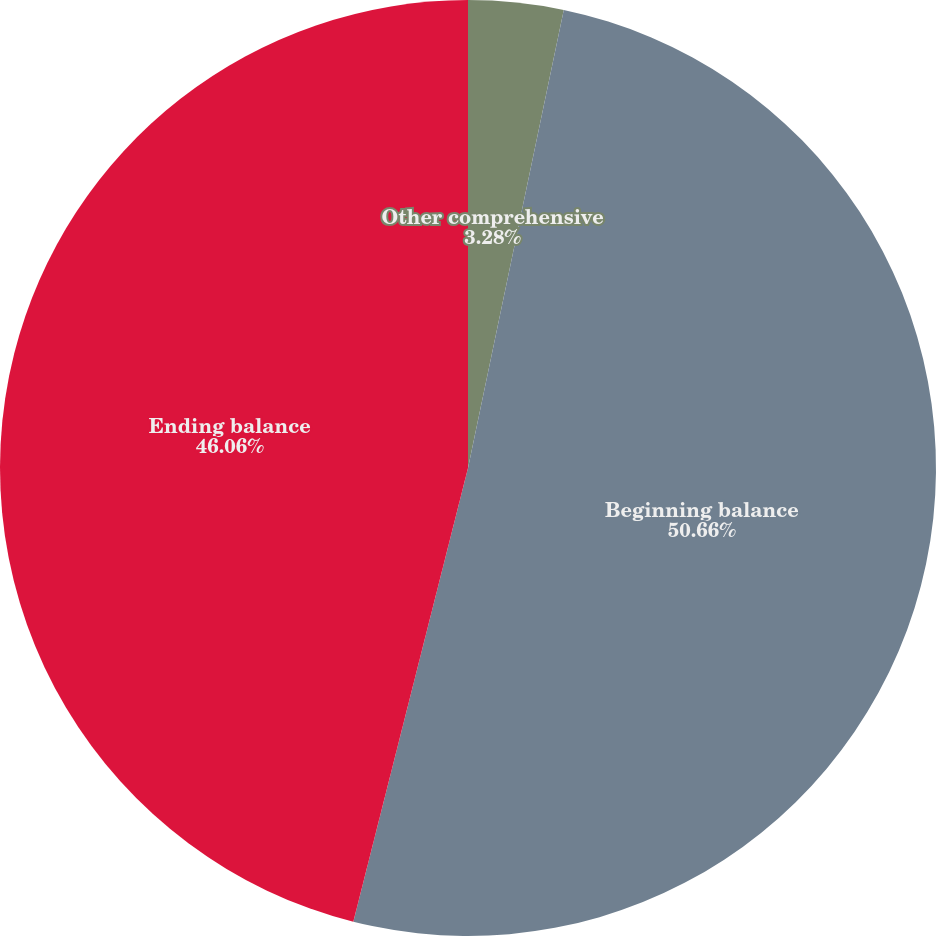Convert chart. <chart><loc_0><loc_0><loc_500><loc_500><pie_chart><fcel>Other comprehensive<fcel>Beginning balance<fcel>Ending balance<nl><fcel>3.28%<fcel>50.66%<fcel>46.06%<nl></chart> 